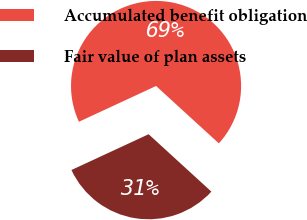Convert chart to OTSL. <chart><loc_0><loc_0><loc_500><loc_500><pie_chart><fcel>Accumulated benefit obligation<fcel>Fair value of plan assets<nl><fcel>68.7%<fcel>31.3%<nl></chart> 